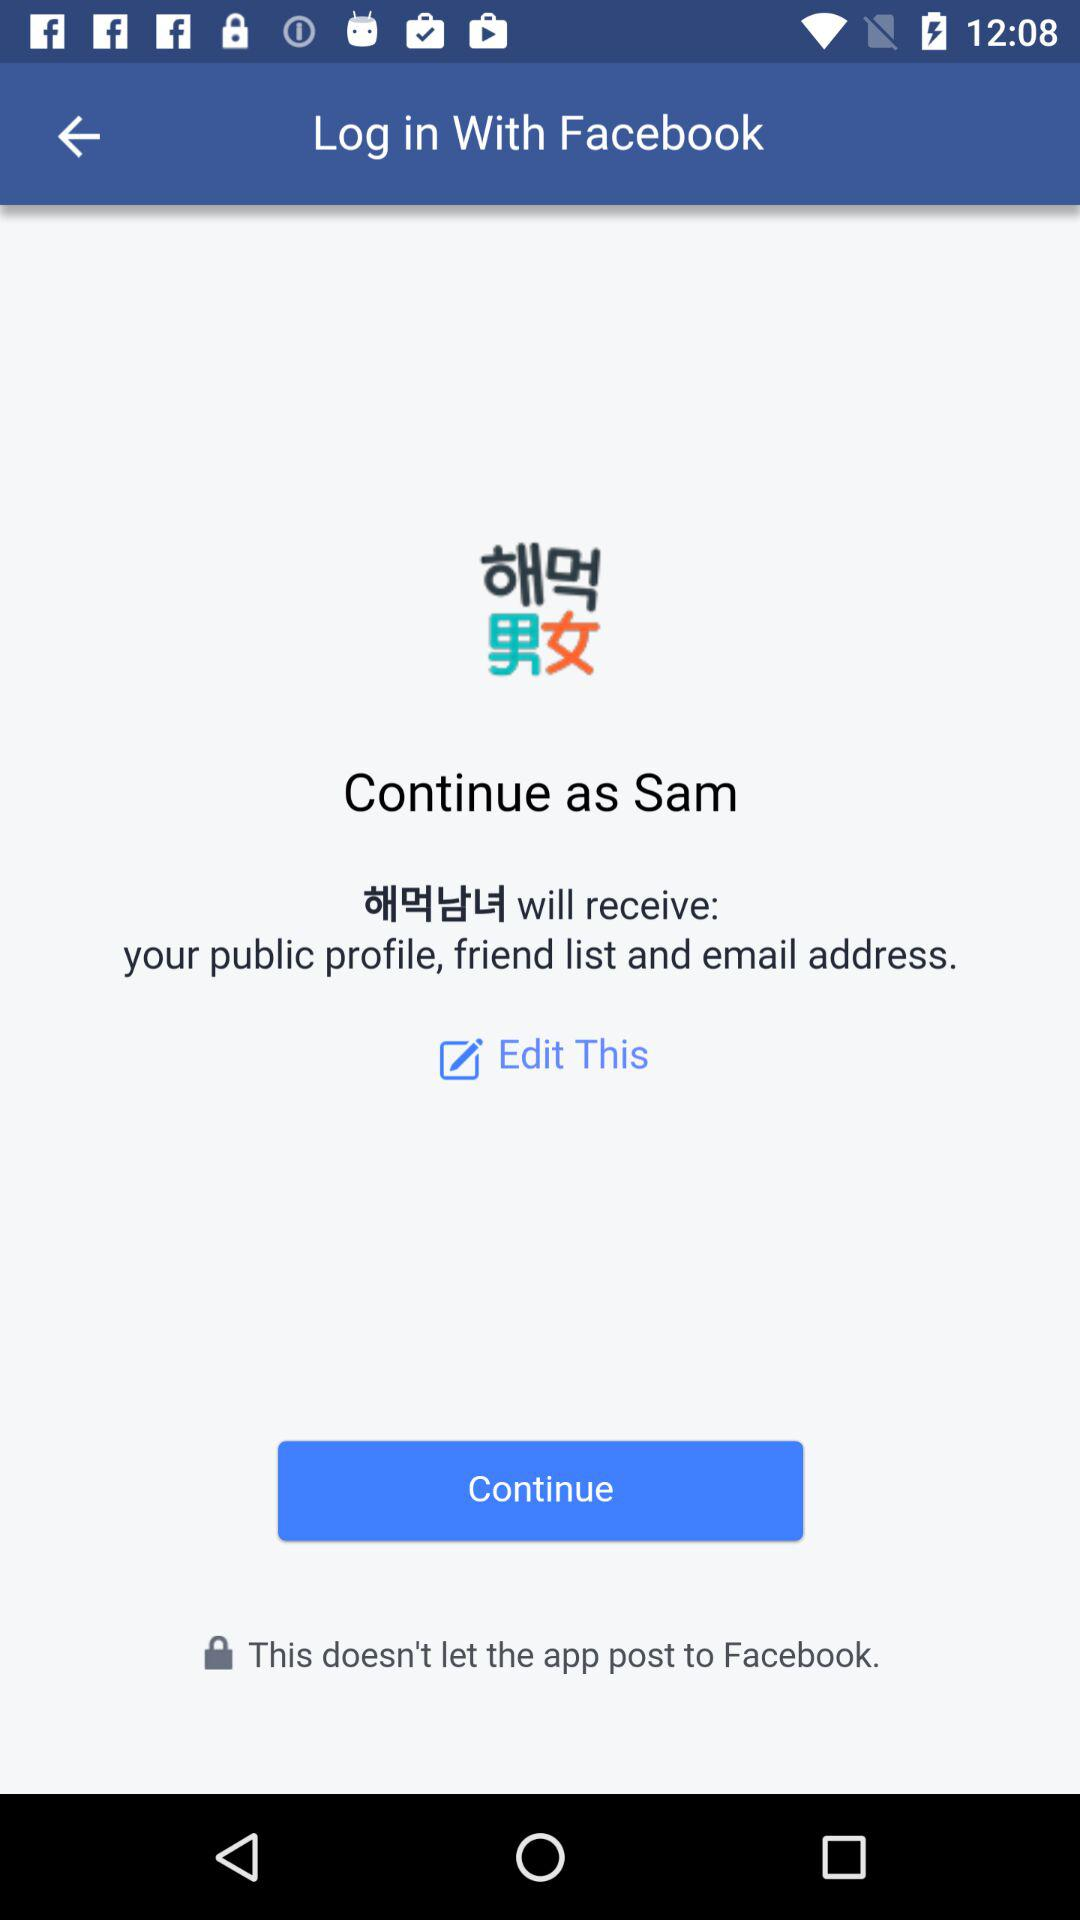What's the user name? The user name is Sam. 